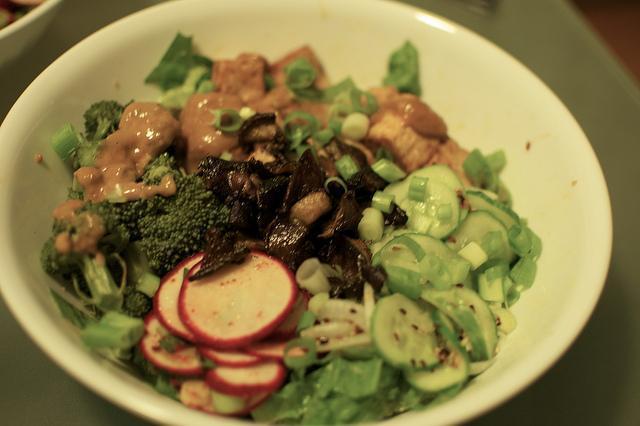How many bowls are there?
Give a very brief answer. 2. How many broccolis are there?
Give a very brief answer. 3. 